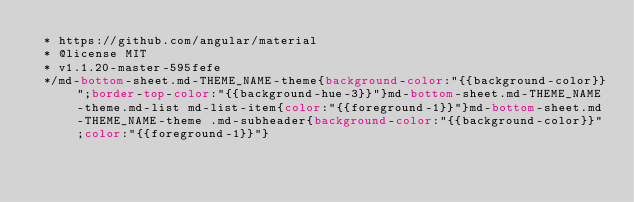Convert code to text. <code><loc_0><loc_0><loc_500><loc_500><_CSS_> * https://github.com/angular/material
 * @license MIT
 * v1.1.20-master-595fefe
 */md-bottom-sheet.md-THEME_NAME-theme{background-color:"{{background-color}}";border-top-color:"{{background-hue-3}}"}md-bottom-sheet.md-THEME_NAME-theme.md-list md-list-item{color:"{{foreground-1}}"}md-bottom-sheet.md-THEME_NAME-theme .md-subheader{background-color:"{{background-color}}";color:"{{foreground-1}}"}</code> 